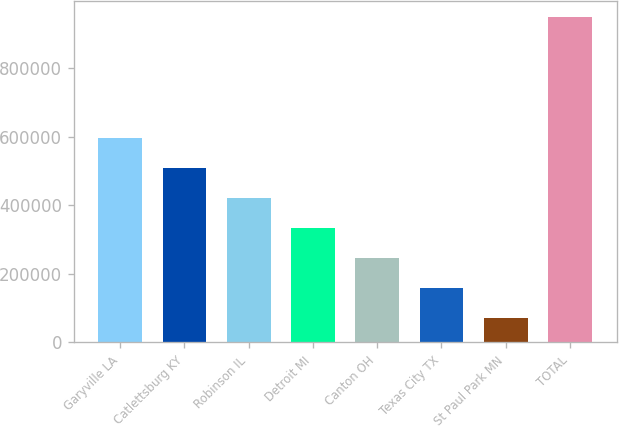Convert chart. <chart><loc_0><loc_0><loc_500><loc_500><bar_chart><fcel>Garyville LA<fcel>Catlettsburg KY<fcel>Robinson IL<fcel>Detroit MI<fcel>Canton OH<fcel>Texas City TX<fcel>St Paul Park MN<fcel>TOTAL<nl><fcel>596800<fcel>509000<fcel>421200<fcel>333400<fcel>245600<fcel>157800<fcel>70000<fcel>948000<nl></chart> 